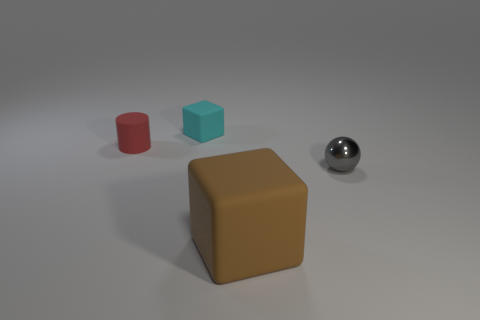Are there any other things that are the same size as the cylinder?
Your response must be concise. Yes. How many other objects are there of the same shape as the metallic object?
Ensure brevity in your answer.  0. Do the large brown object and the object that is right of the big brown object have the same shape?
Make the answer very short. No. What size is the thing that is both in front of the small red thing and behind the brown cube?
Provide a succinct answer. Small. What color is the object that is in front of the cyan block and on the left side of the brown object?
Ensure brevity in your answer.  Red. Is there anything else that has the same material as the small red cylinder?
Provide a succinct answer. Yes. Are there fewer tiny red rubber things behind the big brown block than small gray objects in front of the matte cylinder?
Give a very brief answer. No. Is there anything else that has the same color as the metallic sphere?
Keep it short and to the point. No. What is the shape of the tiny cyan matte thing?
Provide a short and direct response. Cube. The cylinder that is the same material as the tiny block is what color?
Your answer should be very brief. Red. 